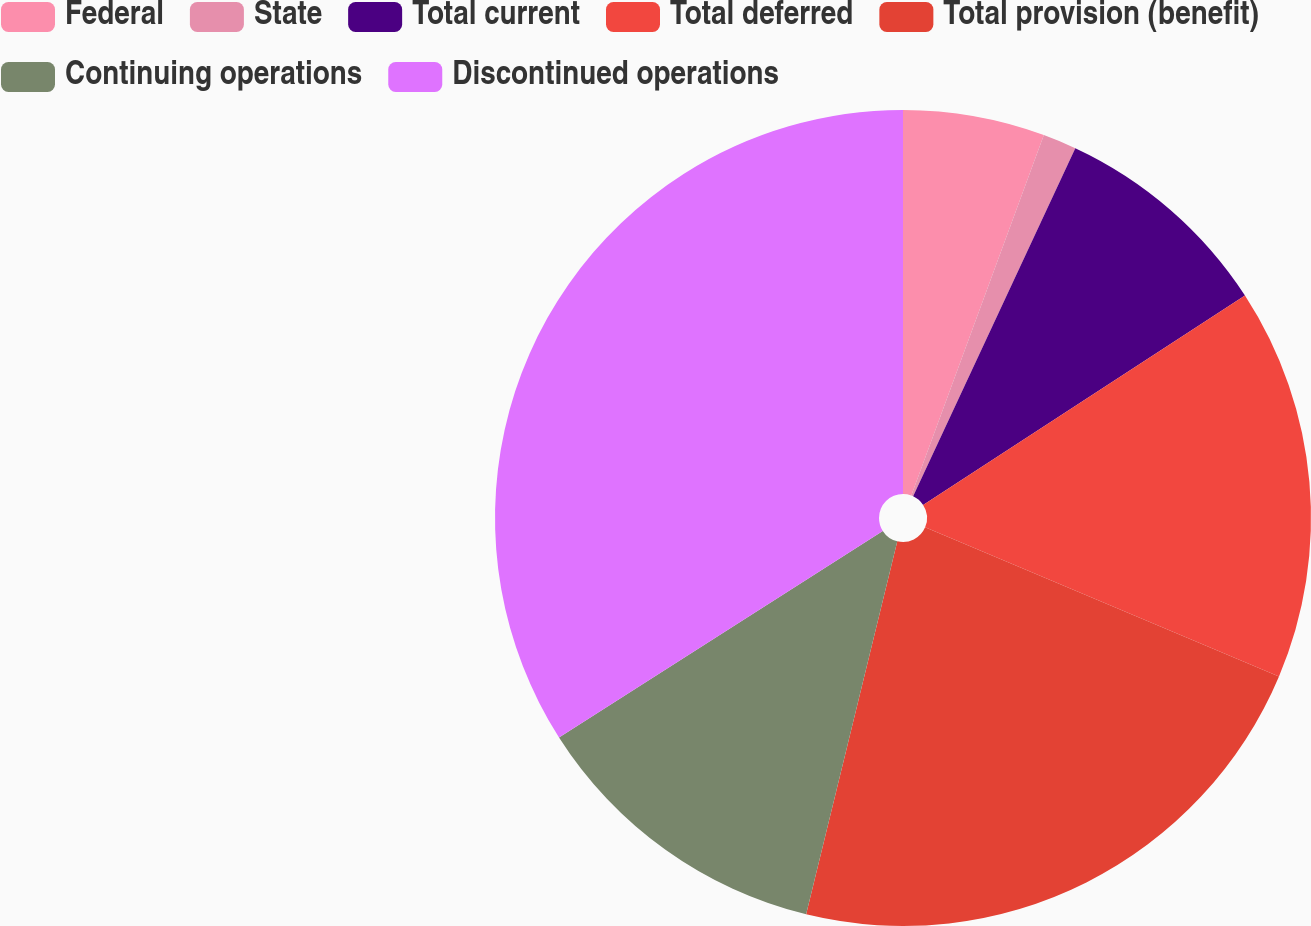Convert chart to OTSL. <chart><loc_0><loc_0><loc_500><loc_500><pie_chart><fcel>Federal<fcel>State<fcel>Total current<fcel>Total deferred<fcel>Total provision (benefit)<fcel>Continuing operations<fcel>Discontinued operations<nl><fcel>5.61%<fcel>1.33%<fcel>8.88%<fcel>15.53%<fcel>22.47%<fcel>12.15%<fcel>34.04%<nl></chart> 